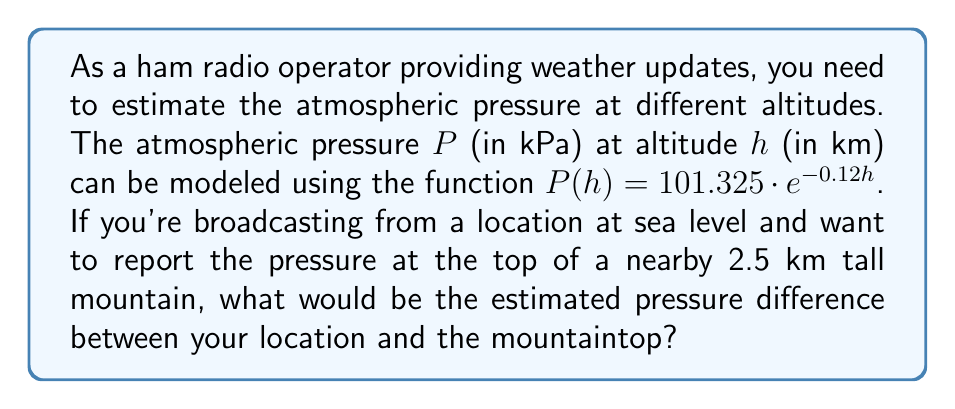Could you help me with this problem? To solve this problem, we need to follow these steps:

1. Calculate the pressure at sea level (h = 0 km):
   $$P(0) = 101.325 \cdot e^{-0.12 \cdot 0} = 101.325 \text{ kPa}$$

2. Calculate the pressure at the mountaintop (h = 2.5 km):
   $$P(2.5) = 101.325 \cdot e^{-0.12 \cdot 2.5} = 101.325 \cdot e^{-0.3}$$
   
   Using a calculator or computer:
   $$P(2.5) \approx 74.6873 \text{ kPa}$$

3. Calculate the pressure difference:
   $$\text{Pressure difference} = P(0) - P(2.5)$$
   $$= 101.325 - 74.6873 = 26.6377 \text{ kPa}$$

4. Round to a reasonable number of significant figures (let's use 3):
   $$\text{Pressure difference} \approx 26.6 \text{ kPa}$$
Answer: 26.6 kPa 